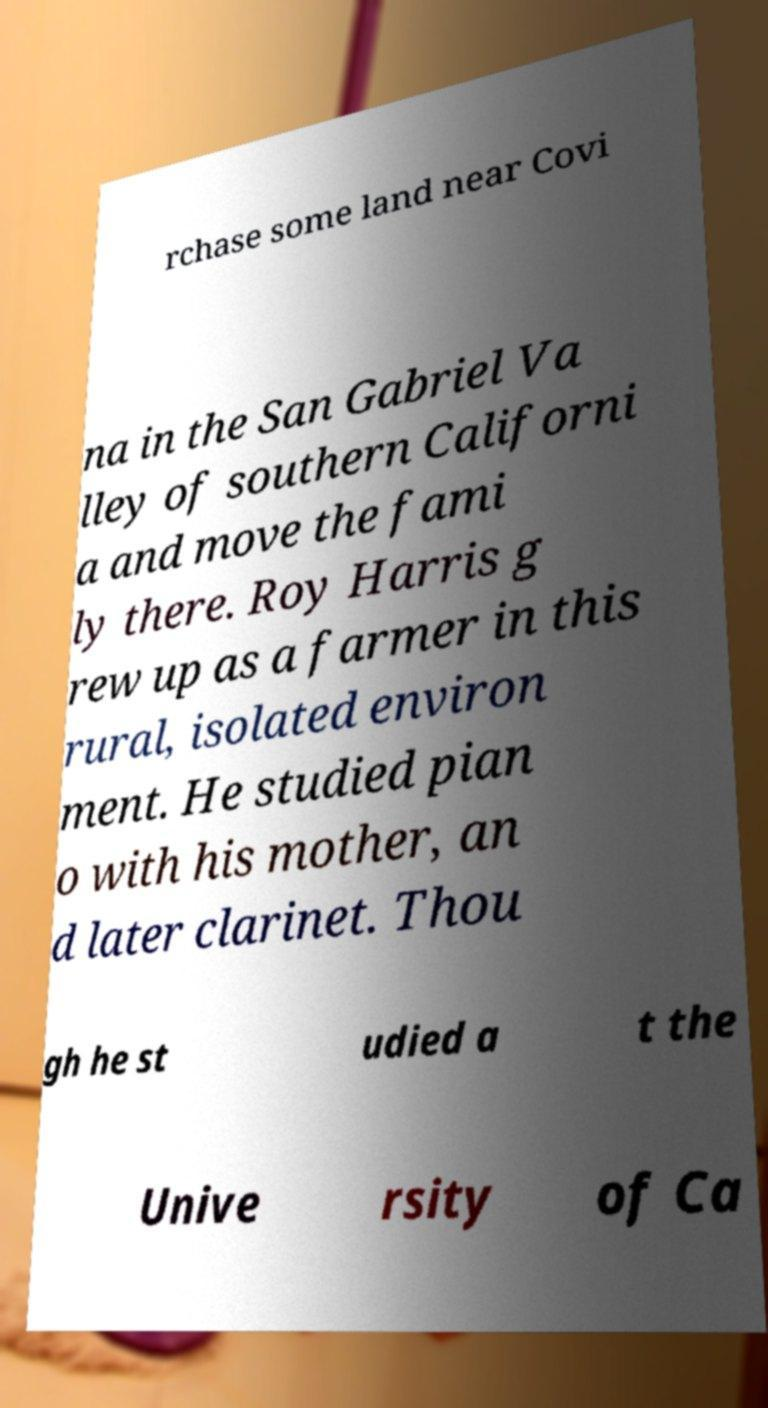Could you extract and type out the text from this image? rchase some land near Covi na in the San Gabriel Va lley of southern Californi a and move the fami ly there. Roy Harris g rew up as a farmer in this rural, isolated environ ment. He studied pian o with his mother, an d later clarinet. Thou gh he st udied a t the Unive rsity of Ca 